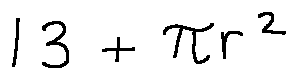<formula> <loc_0><loc_0><loc_500><loc_500>1 3 + \pi r ^ { 2 }</formula> 